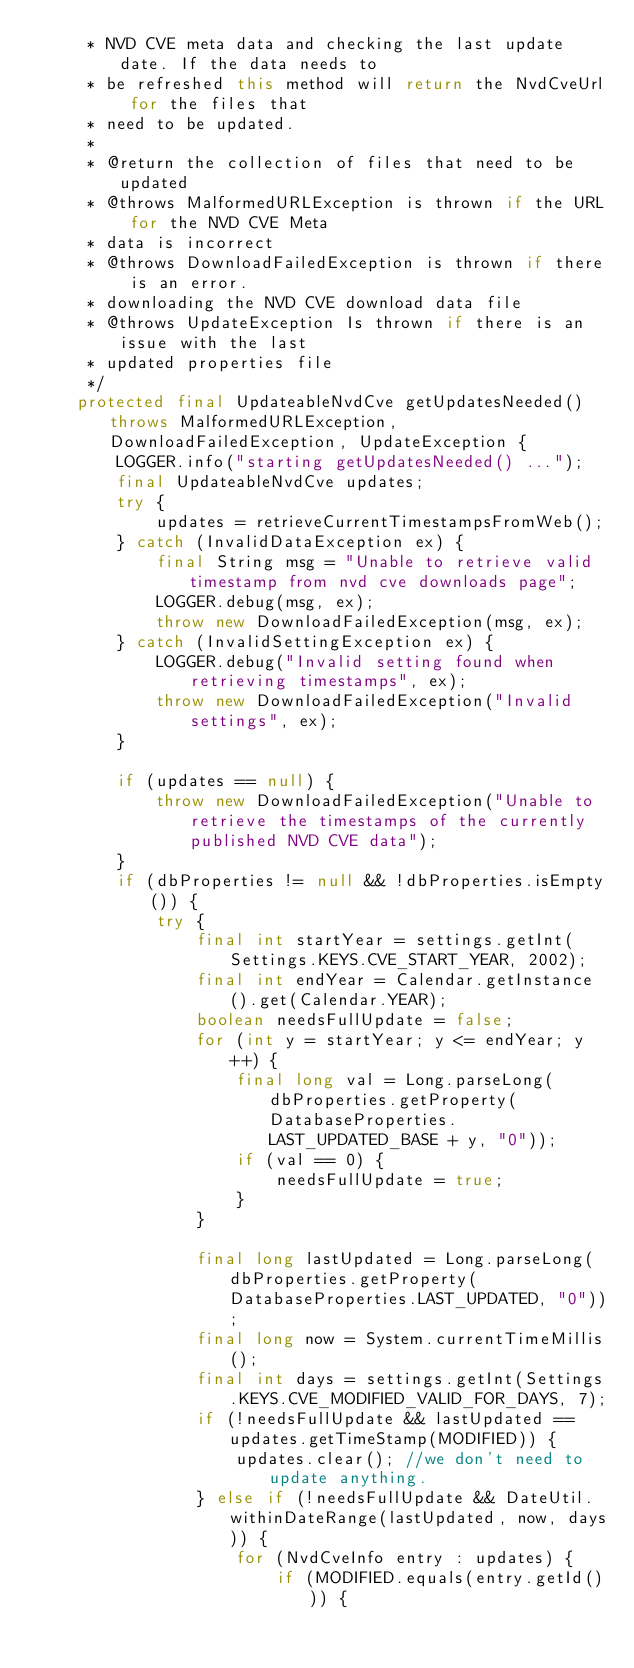<code> <loc_0><loc_0><loc_500><loc_500><_Java_>     * NVD CVE meta data and checking the last update date. If the data needs to
     * be refreshed this method will return the NvdCveUrl for the files that
     * need to be updated.
     *
     * @return the collection of files that need to be updated
     * @throws MalformedURLException is thrown if the URL for the NVD CVE Meta
     * data is incorrect
     * @throws DownloadFailedException is thrown if there is an error.
     * downloading the NVD CVE download data file
     * @throws UpdateException Is thrown if there is an issue with the last
     * updated properties file
     */
    protected final UpdateableNvdCve getUpdatesNeeded() throws MalformedURLException, DownloadFailedException, UpdateException {
        LOGGER.info("starting getUpdatesNeeded() ...");
        final UpdateableNvdCve updates;
        try {
            updates = retrieveCurrentTimestampsFromWeb();
        } catch (InvalidDataException ex) {
            final String msg = "Unable to retrieve valid timestamp from nvd cve downloads page";
            LOGGER.debug(msg, ex);
            throw new DownloadFailedException(msg, ex);
        } catch (InvalidSettingException ex) {
            LOGGER.debug("Invalid setting found when retrieving timestamps", ex);
            throw new DownloadFailedException("Invalid settings", ex);
        }

        if (updates == null) {
            throw new DownloadFailedException("Unable to retrieve the timestamps of the currently published NVD CVE data");
        }
        if (dbProperties != null && !dbProperties.isEmpty()) {
            try {
                final int startYear = settings.getInt(Settings.KEYS.CVE_START_YEAR, 2002);
                final int endYear = Calendar.getInstance().get(Calendar.YEAR);
                boolean needsFullUpdate = false;
                for (int y = startYear; y <= endYear; y++) {
                    final long val = Long.parseLong(dbProperties.getProperty(DatabaseProperties.LAST_UPDATED_BASE + y, "0"));
                    if (val == 0) {
                        needsFullUpdate = true;
                    }
                }

                final long lastUpdated = Long.parseLong(dbProperties.getProperty(DatabaseProperties.LAST_UPDATED, "0"));
                final long now = System.currentTimeMillis();
                final int days = settings.getInt(Settings.KEYS.CVE_MODIFIED_VALID_FOR_DAYS, 7);
                if (!needsFullUpdate && lastUpdated == updates.getTimeStamp(MODIFIED)) {
                    updates.clear(); //we don't need to update anything.
                } else if (!needsFullUpdate && DateUtil.withinDateRange(lastUpdated, now, days)) {
                    for (NvdCveInfo entry : updates) {
                        if (MODIFIED.equals(entry.getId())) {</code> 